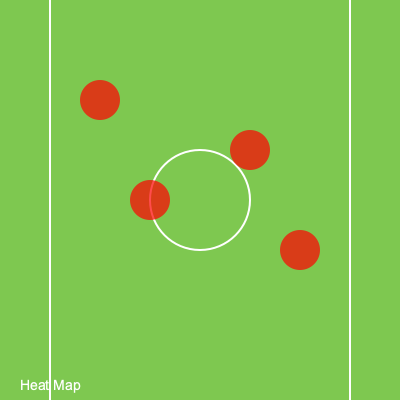Based on the heat map of player positions shown in the image, which area of the pitch appears to be the most effective for initiating attacking plays, and how might you adjust your positioning to complement this pattern? To answer this question, we need to analyze the heat map and consider its implications for gameplay:

1. Observe the heat map: The red circles represent areas of high player concentration or frequent positioning.

2. Identify the most intense area: The highest concentration appears to be in the center-left region of the pitch.

3. Interpret the pattern: This suggests that most attacking plays are being initiated from the left-center midfield area.

4. Consider tactical implications:
   a) The team seems to favor building attacks through the left side.
   b) This could indicate a strong left-footed midfielder or a tactical preference.

5. Adjusting positioning:
   a) As a dynamic duo partner, you could position yourself slightly to the right of this hot zone.
   b) This positioning would provide a passing option to switch play or create space by drawing defenders.

6. Complementary movement:
   a) Make runs into the space behind the defense on the right side.
   b) This movement can exploit the space left when defenders shift to cover the left-side threat.

7. Tactical advantage:
   By positioning yourself to complement this pattern, you can:
   a) Offer an alternative passing option.
   b) Create width in the attack.
   c) Potentially exploit less-defended areas on the right side of the pitch.
Answer: Position slightly right of the left-center midfield hot zone, making runs into space on the right to complement the left-side buildup. 